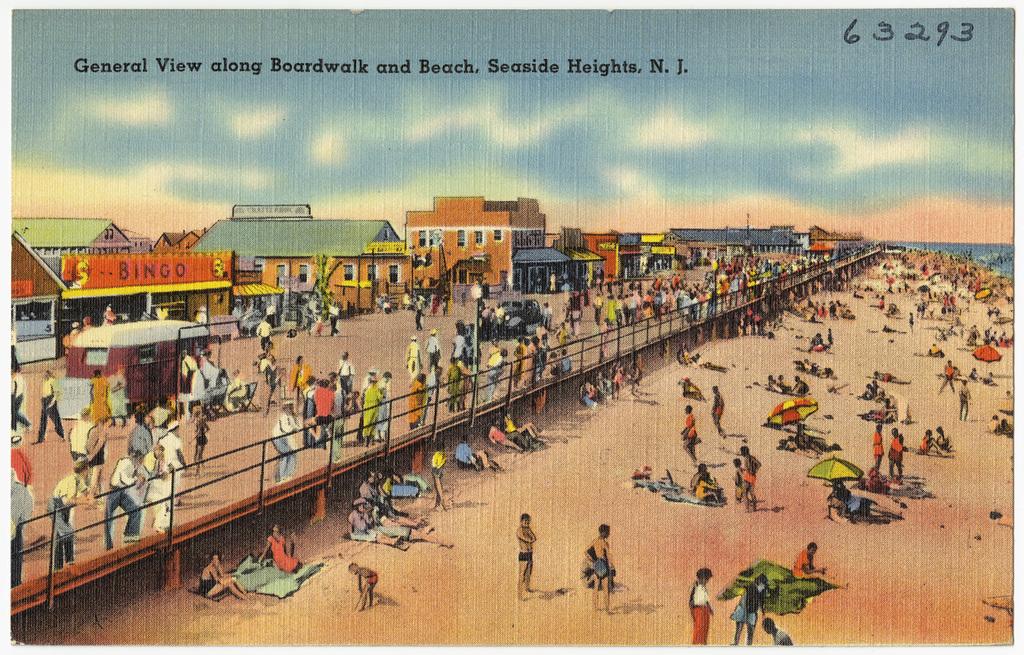What number is in the top right corner?
Offer a terse response. 63293. Where is pictured on the postcard?
Offer a terse response. Seaside heights, n.j. 